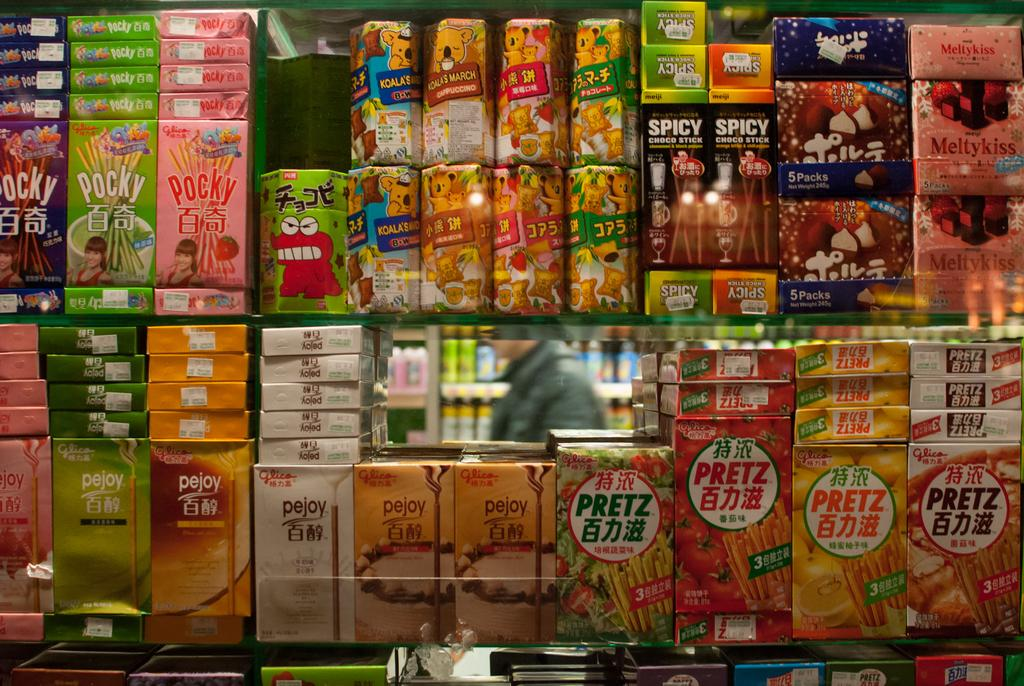<image>
Provide a brief description of the given image. The bottom right corner of the shelve is where the Pretz crackers are held. 